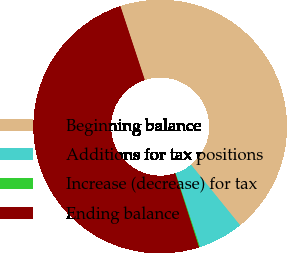Convert chart. <chart><loc_0><loc_0><loc_500><loc_500><pie_chart><fcel>Beginning balance<fcel>Additions for tax positions<fcel>Increase (decrease) for tax<fcel>Ending balance<nl><fcel>44.25%<fcel>5.75%<fcel>0.13%<fcel>49.87%<nl></chart> 